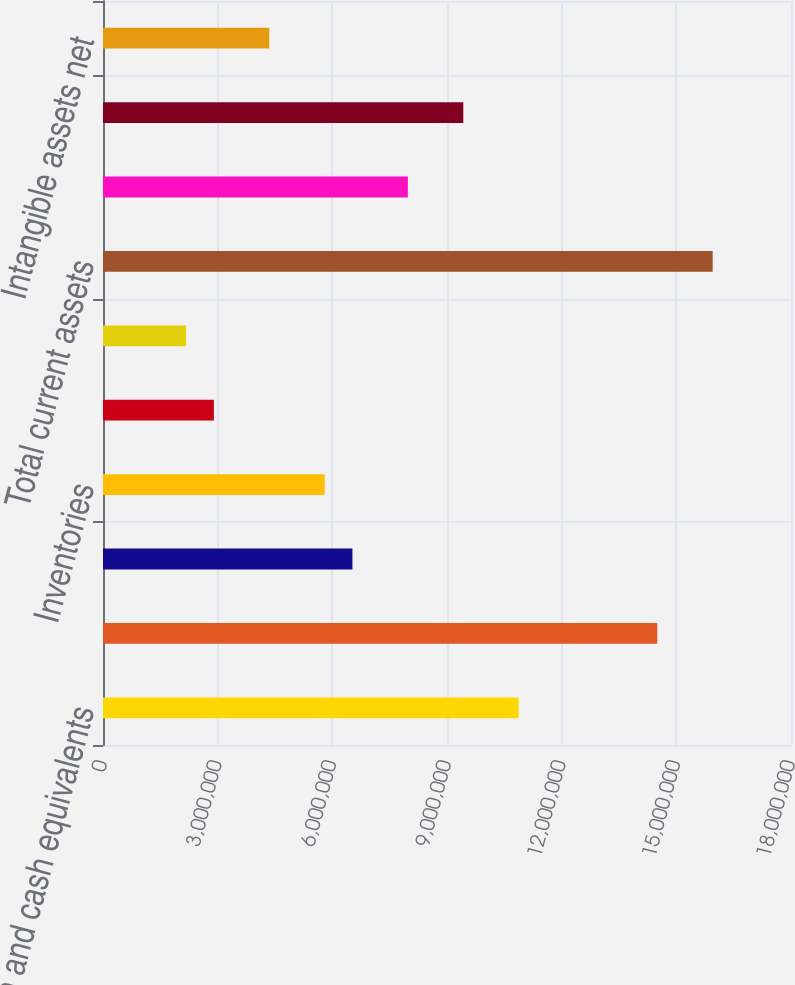Convert chart. <chart><loc_0><loc_0><loc_500><loc_500><bar_chart><fcel>Cash and cash equivalents<fcel>Marketable securities<fcel>Accounts receivable less<fcel>Inventories<fcel>Prepaid expenses and other<fcel>Deferred income taxes<fcel>Total current assets<fcel>Property and equipment net<fcel>Goodwill<fcel>Intangible assets net<nl><fcel>1.0876e+07<fcel>1.45011e+07<fcel>6.52588e+06<fcel>5.80086e+06<fcel>2.9008e+06<fcel>2.17578e+06<fcel>1.59511e+07<fcel>7.97591e+06<fcel>9.42594e+06<fcel>4.35083e+06<nl></chart> 